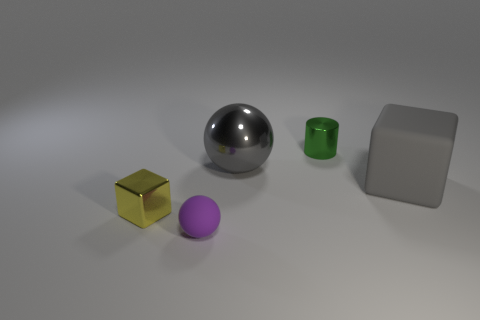Add 2 large brown metal balls. How many objects exist? 7 Subtract all cubes. How many objects are left? 3 Subtract 1 gray spheres. How many objects are left? 4 Subtract 1 cylinders. How many cylinders are left? 0 Subtract all cyan cubes. Subtract all brown spheres. How many cubes are left? 2 Subtract all red blocks. How many blue spheres are left? 0 Subtract all brown rubber blocks. Subtract all small purple matte things. How many objects are left? 4 Add 2 purple objects. How many purple objects are left? 3 Add 2 gray rubber objects. How many gray rubber objects exist? 3 